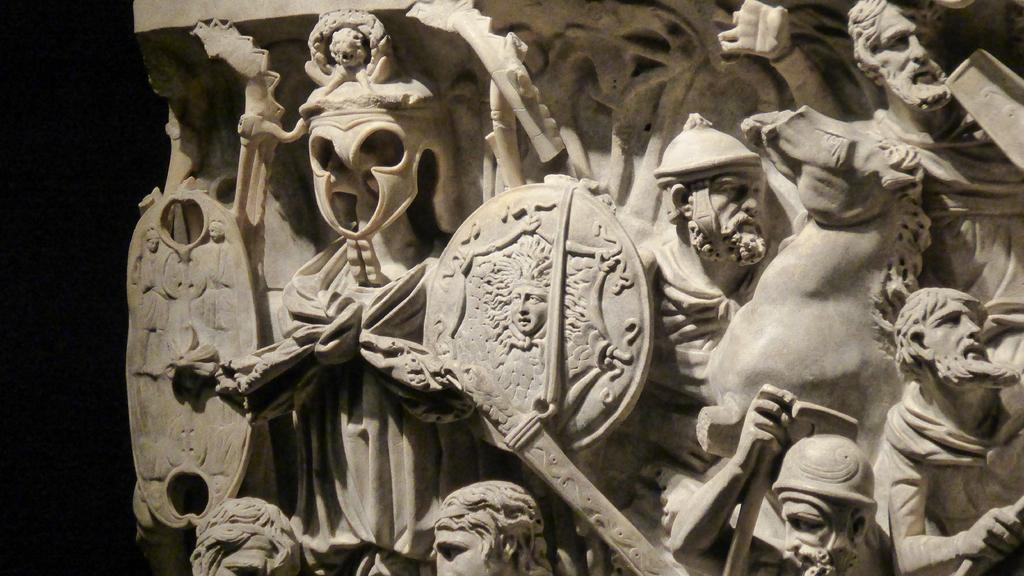What type of art is present in the image? There are sculptures in the image. What type of noise can be heard coming from the sculptures in the image? There is no noise coming from the sculptures in the image, as sculptures are typically silent and inanimate objects. 